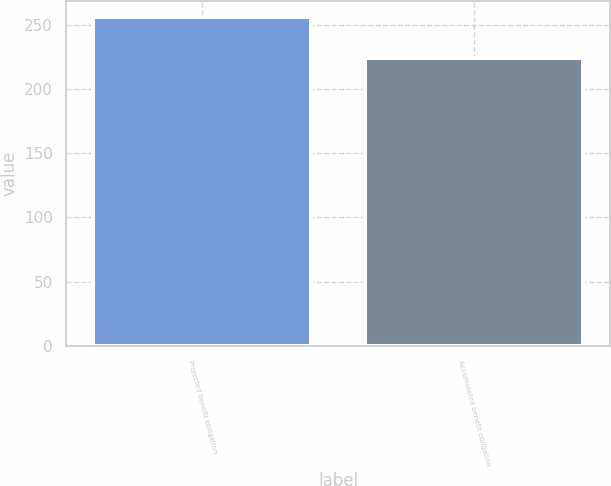Convert chart to OTSL. <chart><loc_0><loc_0><loc_500><loc_500><bar_chart><fcel>Projected benefit obligation<fcel>Accumulated benefit obligation<nl><fcel>255.5<fcel>224.1<nl></chart> 